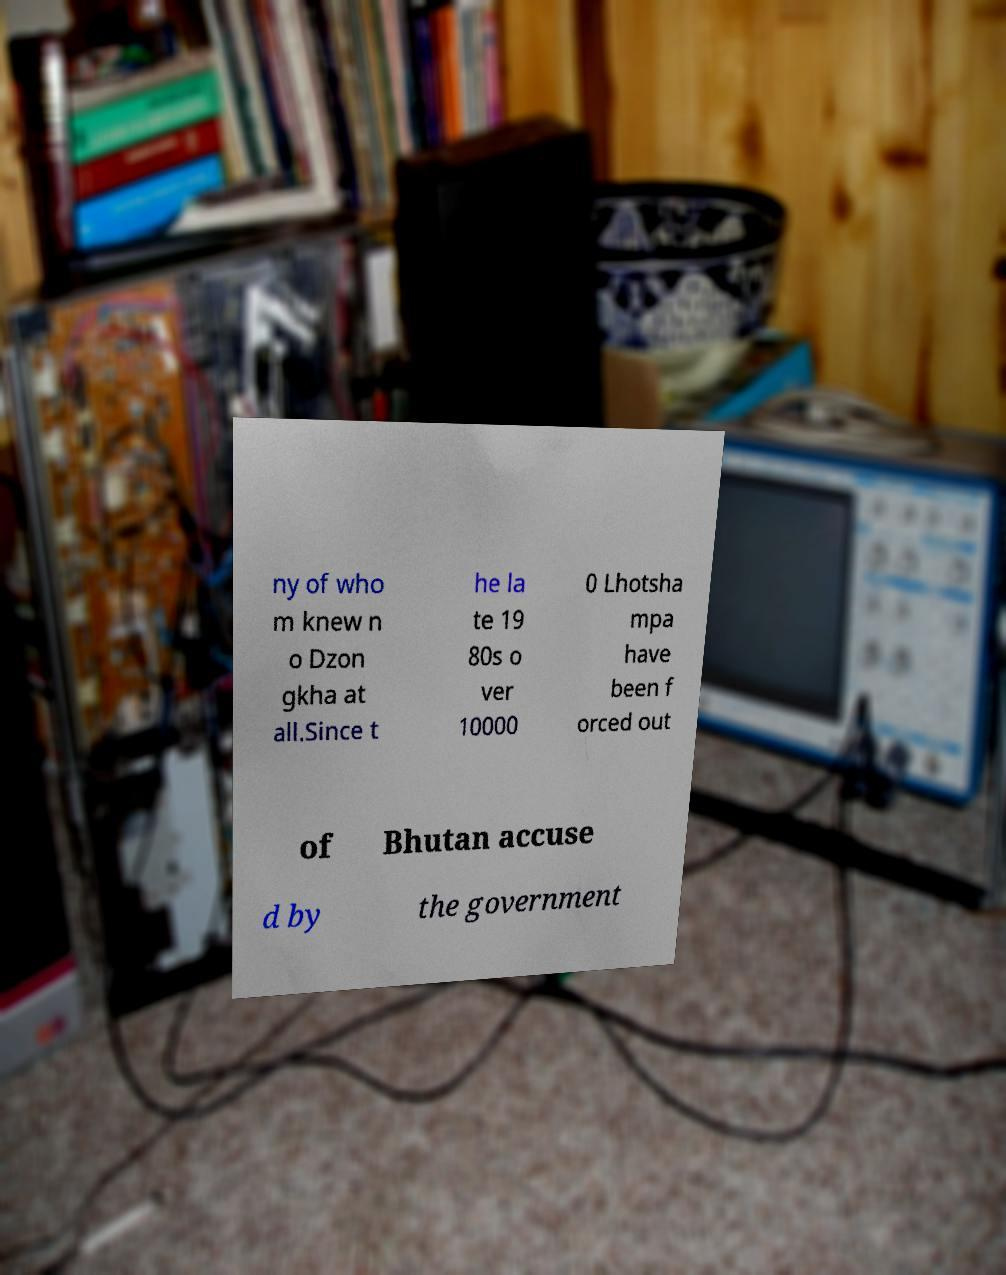What messages or text are displayed in this image? I need them in a readable, typed format. ny of who m knew n o Dzon gkha at all.Since t he la te 19 80s o ver 10000 0 Lhotsha mpa have been f orced out of Bhutan accuse d by the government 